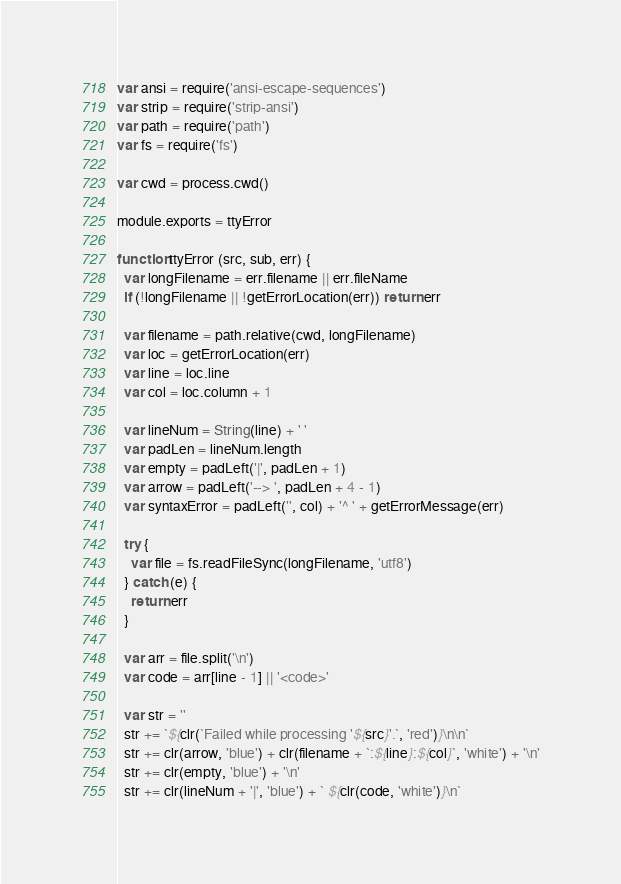Convert code to text. <code><loc_0><loc_0><loc_500><loc_500><_JavaScript_>var ansi = require('ansi-escape-sequences')
var strip = require('strip-ansi')
var path = require('path')
var fs = require('fs')

var cwd = process.cwd()

module.exports = ttyError

function ttyError (src, sub, err) {
  var longFilename = err.filename || err.fileName
  if (!longFilename || !getErrorLocation(err)) return err

  var filename = path.relative(cwd, longFilename)
  var loc = getErrorLocation(err)
  var line = loc.line
  var col = loc.column + 1

  var lineNum = String(line) + ' '
  var padLen = lineNum.length
  var empty = padLeft('|', padLen + 1)
  var arrow = padLeft('--> ', padLen + 4 - 1)
  var syntaxError = padLeft('', col) + '^ ' + getErrorMessage(err)

  try {
    var file = fs.readFileSync(longFilename, 'utf8')
  } catch (e) {
    return err
  }

  var arr = file.split('\n')
  var code = arr[line - 1] || '<code>'

  var str = ''
  str += `${clr(`Failed while processing '${src}'.`, 'red')}\n\n`
  str += clr(arrow, 'blue') + clr(filename + `:${line}:${col}`, 'white') + '\n'
  str += clr(empty, 'blue') + '\n'
  str += clr(lineNum + '|', 'blue') + ` ${clr(code, 'white')}\n`</code> 